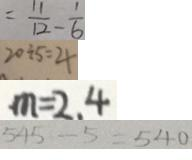Convert formula to latex. <formula><loc_0><loc_0><loc_500><loc_500>= \frac { 1 1 } { 1 2 } - \frac { 1 } { 6 } 
 2 0 \div 5 = 4 
 m = 2 . 4 
 5 4 5 - 5 = 5 4 0</formula> 